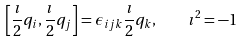Convert formula to latex. <formula><loc_0><loc_0><loc_500><loc_500>\left [ \frac { \imath } { 2 } q _ { i } , \frac { \imath } { 2 } q _ { j } \right ] = \epsilon _ { i j k } \frac { \imath } { 2 } q _ { k } , \quad \imath ^ { 2 } = - 1</formula> 